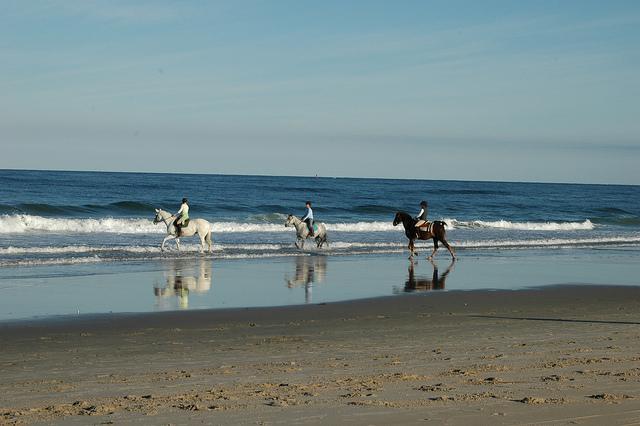What are these people doing?
Give a very brief answer. Riding horses. How many waves are coming in?
Answer briefly. 2. Are the horses drowning?
Quick response, please. No. How many horses are on the beach?
Give a very brief answer. 3. 